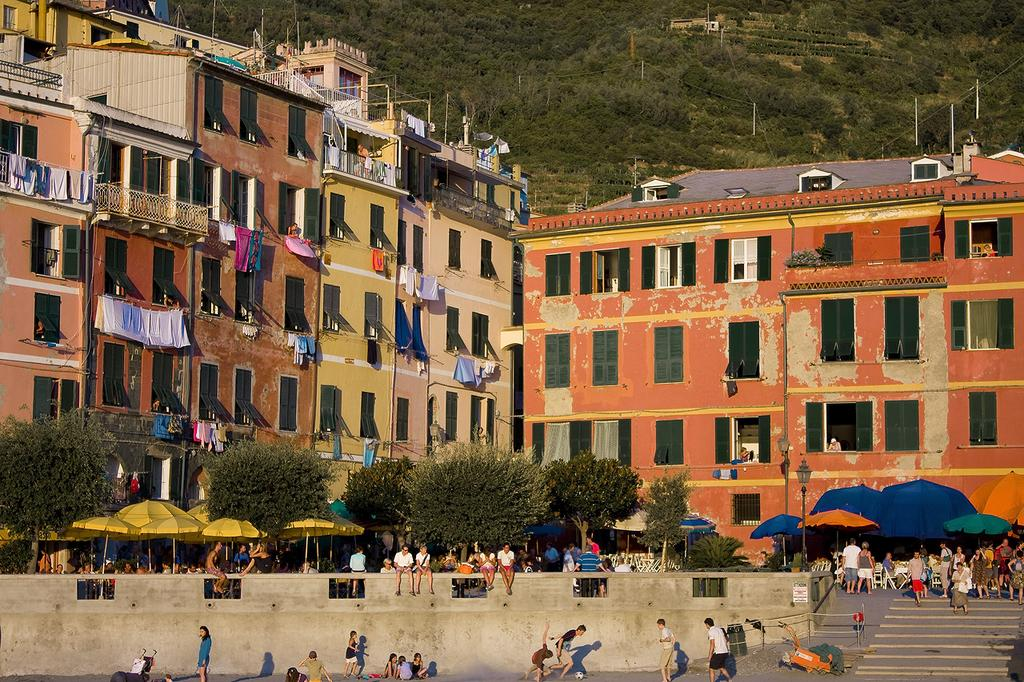What is the main subject in the center of the image? There are buildings in the center of the image. Where are the people located in the image? The people are at the bottom side of the image. What type of vegetation is at the top side of the image? There are trees at the top side of the image. What type of yam can be seen growing on the trees in the image? There are no yams present in the image; it features buildings, people, and trees. How many roses are visible on the people in the image? There are no roses visible on the people in the image. 